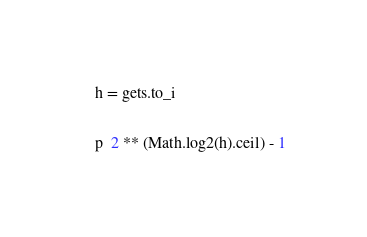<code> <loc_0><loc_0><loc_500><loc_500><_Ruby_>h = gets.to_i

p  2 ** (Math.log2(h).ceil) - 1</code> 